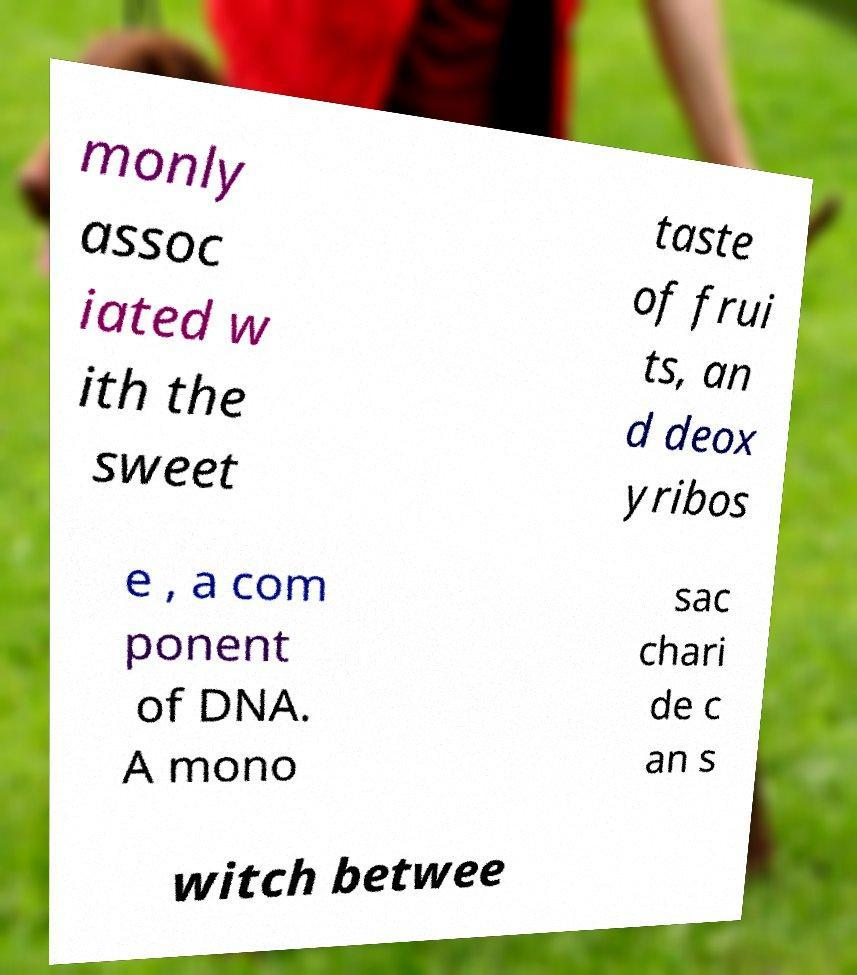Can you tell me more about deoxyribose and its significance? Deoxyribose is a crucial component of DNA, serving as the sugar portion of the nucleotides that make up the DNA molecule. It helps form the backbone of the DNA structure, along which genetic information is encoded. The presence of deoxyribose differentiates DNA from RNA, which contains ribose sugar. 